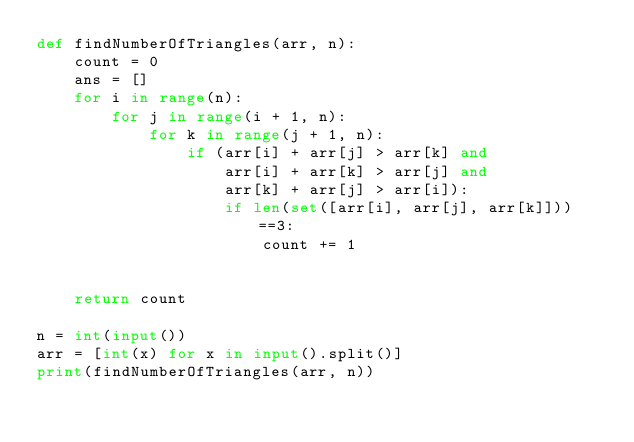<code> <loc_0><loc_0><loc_500><loc_500><_Python_>def findNumberOfTriangles(arr, n):
    count = 0
    ans = []
    for i in range(n):
        for j in range(i + 1, n):
            for k in range(j + 1, n):
                if (arr[i] + arr[j] > arr[k] and
                    arr[i] + arr[k] > arr[j] and
                    arr[k] + arr[j] > arr[i]):
                    if len(set([arr[i], arr[j], arr[k]]))==3:
                        count += 1


    return count

n = int(input())
arr = [int(x) for x in input().split()]
print(findNumberOfTriangles(arr, n))</code> 